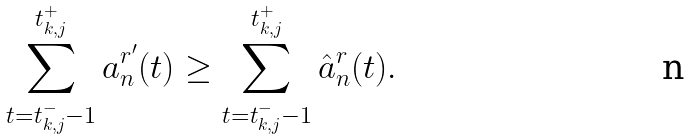Convert formula to latex. <formula><loc_0><loc_0><loc_500><loc_500>\sum _ { t = t _ { k , j } ^ { - } - 1 } ^ { t _ { k , j } ^ { + } } a _ { n } ^ { r ^ { \prime } } ( t ) \geq \sum _ { t = t _ { k , j } ^ { - } - 1 } ^ { t _ { k , j } ^ { + } } \hat { a } _ { n } ^ { r } ( t ) .</formula> 